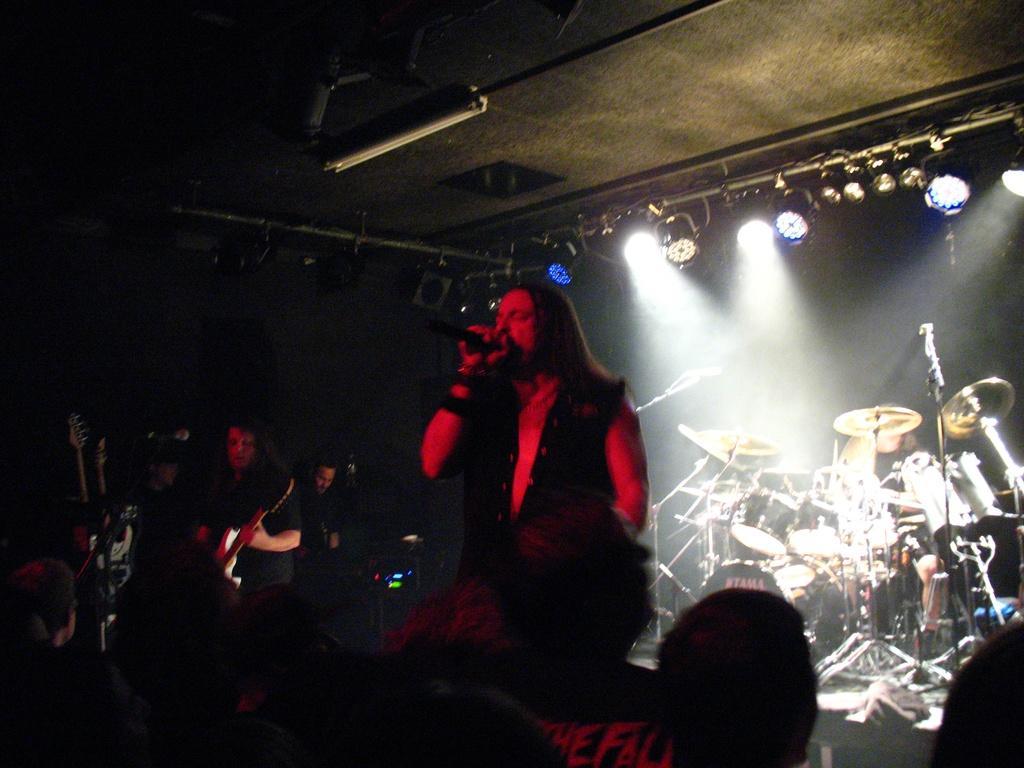Describe this image in one or two sentences. This picture describes about group of people, in the left side of the image we can see a man, he is holding a guitar, in the middle of the image we can see another man, he is holding a microphone, in the background we can find few musical instruments, metal rods and lights. 